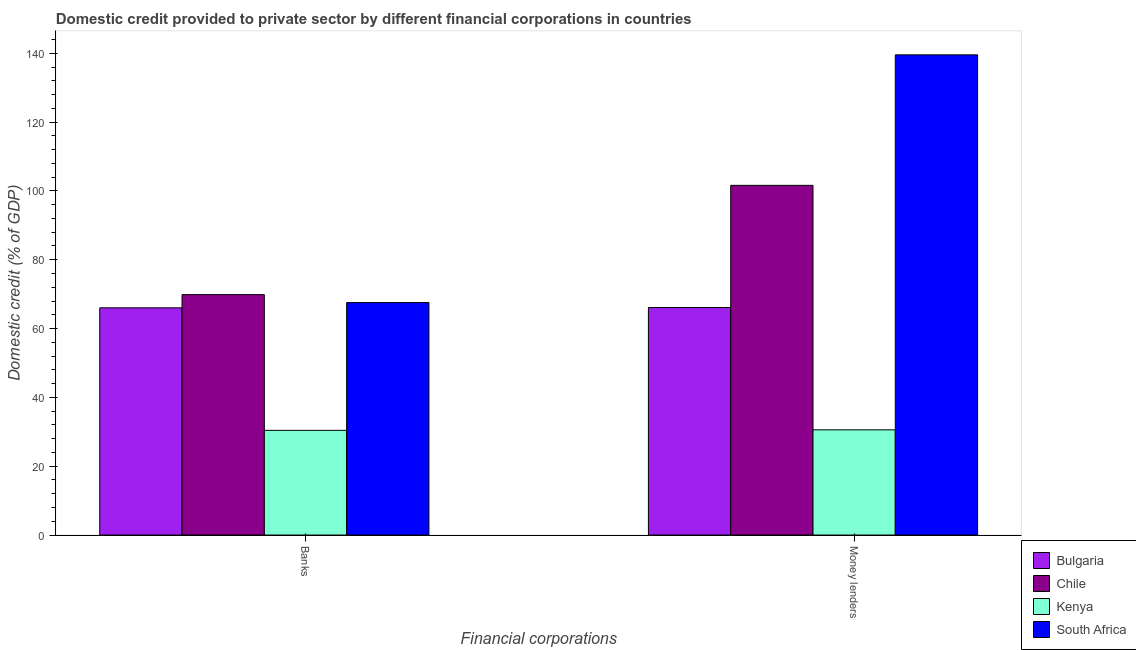How many different coloured bars are there?
Make the answer very short. 4. Are the number of bars per tick equal to the number of legend labels?
Provide a short and direct response. Yes. How many bars are there on the 1st tick from the right?
Your answer should be very brief. 4. What is the label of the 2nd group of bars from the left?
Give a very brief answer. Money lenders. What is the domestic credit provided by money lenders in South Africa?
Your answer should be compact. 139.54. Across all countries, what is the maximum domestic credit provided by money lenders?
Give a very brief answer. 139.54. Across all countries, what is the minimum domestic credit provided by banks?
Provide a succinct answer. 30.42. In which country was the domestic credit provided by money lenders maximum?
Your response must be concise. South Africa. In which country was the domestic credit provided by money lenders minimum?
Your answer should be compact. Kenya. What is the total domestic credit provided by banks in the graph?
Provide a short and direct response. 233.87. What is the difference between the domestic credit provided by money lenders in South Africa and that in Chile?
Ensure brevity in your answer.  37.93. What is the difference between the domestic credit provided by banks in South Africa and the domestic credit provided by money lenders in Kenya?
Your answer should be very brief. 36.98. What is the average domestic credit provided by banks per country?
Provide a short and direct response. 58.47. What is the difference between the domestic credit provided by money lenders and domestic credit provided by banks in Kenya?
Ensure brevity in your answer.  0.15. In how many countries, is the domestic credit provided by banks greater than 84 %?
Keep it short and to the point. 0. What is the ratio of the domestic credit provided by banks in Chile to that in Bulgaria?
Provide a short and direct response. 1.06. Is the domestic credit provided by banks in Chile less than that in Bulgaria?
Keep it short and to the point. No. What does the 4th bar from the left in Money lenders represents?
Ensure brevity in your answer.  South Africa. What does the 2nd bar from the right in Money lenders represents?
Your answer should be very brief. Kenya. Are all the bars in the graph horizontal?
Ensure brevity in your answer.  No. What is the difference between two consecutive major ticks on the Y-axis?
Your response must be concise. 20. Are the values on the major ticks of Y-axis written in scientific E-notation?
Offer a very short reply. No. Does the graph contain grids?
Ensure brevity in your answer.  No. Where does the legend appear in the graph?
Give a very brief answer. Bottom right. What is the title of the graph?
Provide a succinct answer. Domestic credit provided to private sector by different financial corporations in countries. Does "Venezuela" appear as one of the legend labels in the graph?
Provide a succinct answer. No. What is the label or title of the X-axis?
Keep it short and to the point. Financial corporations. What is the label or title of the Y-axis?
Make the answer very short. Domestic credit (% of GDP). What is the Domestic credit (% of GDP) of Bulgaria in Banks?
Keep it short and to the point. 66.03. What is the Domestic credit (% of GDP) in Chile in Banks?
Provide a short and direct response. 69.86. What is the Domestic credit (% of GDP) in Kenya in Banks?
Offer a very short reply. 30.42. What is the Domestic credit (% of GDP) of South Africa in Banks?
Your answer should be very brief. 67.56. What is the Domestic credit (% of GDP) of Bulgaria in Money lenders?
Keep it short and to the point. 66.12. What is the Domestic credit (% of GDP) in Chile in Money lenders?
Keep it short and to the point. 101.62. What is the Domestic credit (% of GDP) of Kenya in Money lenders?
Provide a short and direct response. 30.57. What is the Domestic credit (% of GDP) of South Africa in Money lenders?
Keep it short and to the point. 139.54. Across all Financial corporations, what is the maximum Domestic credit (% of GDP) of Bulgaria?
Keep it short and to the point. 66.12. Across all Financial corporations, what is the maximum Domestic credit (% of GDP) in Chile?
Make the answer very short. 101.62. Across all Financial corporations, what is the maximum Domestic credit (% of GDP) in Kenya?
Make the answer very short. 30.57. Across all Financial corporations, what is the maximum Domestic credit (% of GDP) in South Africa?
Your answer should be very brief. 139.54. Across all Financial corporations, what is the minimum Domestic credit (% of GDP) of Bulgaria?
Provide a short and direct response. 66.03. Across all Financial corporations, what is the minimum Domestic credit (% of GDP) of Chile?
Ensure brevity in your answer.  69.86. Across all Financial corporations, what is the minimum Domestic credit (% of GDP) in Kenya?
Provide a short and direct response. 30.42. Across all Financial corporations, what is the minimum Domestic credit (% of GDP) in South Africa?
Provide a short and direct response. 67.56. What is the total Domestic credit (% of GDP) in Bulgaria in the graph?
Offer a very short reply. 132.14. What is the total Domestic credit (% of GDP) of Chile in the graph?
Your response must be concise. 171.48. What is the total Domestic credit (% of GDP) in Kenya in the graph?
Make the answer very short. 60.99. What is the total Domestic credit (% of GDP) of South Africa in the graph?
Ensure brevity in your answer.  207.1. What is the difference between the Domestic credit (% of GDP) in Bulgaria in Banks and that in Money lenders?
Your response must be concise. -0.09. What is the difference between the Domestic credit (% of GDP) in Chile in Banks and that in Money lenders?
Give a very brief answer. -31.76. What is the difference between the Domestic credit (% of GDP) of Kenya in Banks and that in Money lenders?
Give a very brief answer. -0.15. What is the difference between the Domestic credit (% of GDP) of South Africa in Banks and that in Money lenders?
Offer a very short reply. -71.99. What is the difference between the Domestic credit (% of GDP) of Bulgaria in Banks and the Domestic credit (% of GDP) of Chile in Money lenders?
Offer a terse response. -35.59. What is the difference between the Domestic credit (% of GDP) of Bulgaria in Banks and the Domestic credit (% of GDP) of Kenya in Money lenders?
Keep it short and to the point. 35.46. What is the difference between the Domestic credit (% of GDP) in Bulgaria in Banks and the Domestic credit (% of GDP) in South Africa in Money lenders?
Your answer should be compact. -73.51. What is the difference between the Domestic credit (% of GDP) of Chile in Banks and the Domestic credit (% of GDP) of Kenya in Money lenders?
Provide a succinct answer. 39.29. What is the difference between the Domestic credit (% of GDP) in Chile in Banks and the Domestic credit (% of GDP) in South Africa in Money lenders?
Give a very brief answer. -69.68. What is the difference between the Domestic credit (% of GDP) in Kenya in Banks and the Domestic credit (% of GDP) in South Africa in Money lenders?
Provide a succinct answer. -109.12. What is the average Domestic credit (% of GDP) in Bulgaria per Financial corporations?
Your response must be concise. 66.07. What is the average Domestic credit (% of GDP) in Chile per Financial corporations?
Offer a terse response. 85.74. What is the average Domestic credit (% of GDP) in Kenya per Financial corporations?
Your answer should be very brief. 30.5. What is the average Domestic credit (% of GDP) in South Africa per Financial corporations?
Make the answer very short. 103.55. What is the difference between the Domestic credit (% of GDP) in Bulgaria and Domestic credit (% of GDP) in Chile in Banks?
Provide a short and direct response. -3.83. What is the difference between the Domestic credit (% of GDP) in Bulgaria and Domestic credit (% of GDP) in Kenya in Banks?
Make the answer very short. 35.61. What is the difference between the Domestic credit (% of GDP) of Bulgaria and Domestic credit (% of GDP) of South Africa in Banks?
Offer a terse response. -1.53. What is the difference between the Domestic credit (% of GDP) of Chile and Domestic credit (% of GDP) of Kenya in Banks?
Provide a short and direct response. 39.44. What is the difference between the Domestic credit (% of GDP) in Chile and Domestic credit (% of GDP) in South Africa in Banks?
Your answer should be very brief. 2.31. What is the difference between the Domestic credit (% of GDP) of Kenya and Domestic credit (% of GDP) of South Africa in Banks?
Provide a succinct answer. -37.14. What is the difference between the Domestic credit (% of GDP) in Bulgaria and Domestic credit (% of GDP) in Chile in Money lenders?
Provide a succinct answer. -35.5. What is the difference between the Domestic credit (% of GDP) of Bulgaria and Domestic credit (% of GDP) of Kenya in Money lenders?
Ensure brevity in your answer.  35.54. What is the difference between the Domestic credit (% of GDP) in Bulgaria and Domestic credit (% of GDP) in South Africa in Money lenders?
Provide a succinct answer. -73.43. What is the difference between the Domestic credit (% of GDP) in Chile and Domestic credit (% of GDP) in Kenya in Money lenders?
Ensure brevity in your answer.  71.04. What is the difference between the Domestic credit (% of GDP) in Chile and Domestic credit (% of GDP) in South Africa in Money lenders?
Offer a terse response. -37.93. What is the difference between the Domestic credit (% of GDP) of Kenya and Domestic credit (% of GDP) of South Africa in Money lenders?
Keep it short and to the point. -108.97. What is the ratio of the Domestic credit (% of GDP) of Bulgaria in Banks to that in Money lenders?
Your answer should be compact. 1. What is the ratio of the Domestic credit (% of GDP) of Chile in Banks to that in Money lenders?
Keep it short and to the point. 0.69. What is the ratio of the Domestic credit (% of GDP) of South Africa in Banks to that in Money lenders?
Keep it short and to the point. 0.48. What is the difference between the highest and the second highest Domestic credit (% of GDP) in Bulgaria?
Ensure brevity in your answer.  0.09. What is the difference between the highest and the second highest Domestic credit (% of GDP) in Chile?
Ensure brevity in your answer.  31.76. What is the difference between the highest and the second highest Domestic credit (% of GDP) of Kenya?
Provide a succinct answer. 0.15. What is the difference between the highest and the second highest Domestic credit (% of GDP) of South Africa?
Your answer should be very brief. 71.99. What is the difference between the highest and the lowest Domestic credit (% of GDP) of Bulgaria?
Offer a terse response. 0.09. What is the difference between the highest and the lowest Domestic credit (% of GDP) in Chile?
Your answer should be compact. 31.76. What is the difference between the highest and the lowest Domestic credit (% of GDP) in Kenya?
Provide a short and direct response. 0.15. What is the difference between the highest and the lowest Domestic credit (% of GDP) in South Africa?
Ensure brevity in your answer.  71.99. 